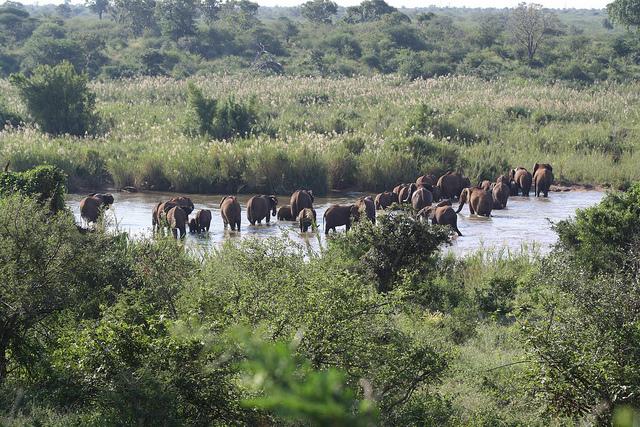Is the sitting of the scene in the circus?
Concise answer only. No. Are animals moving in same direction?
Quick response, please. Yes. What type of water are the animals in?
Concise answer only. River. 